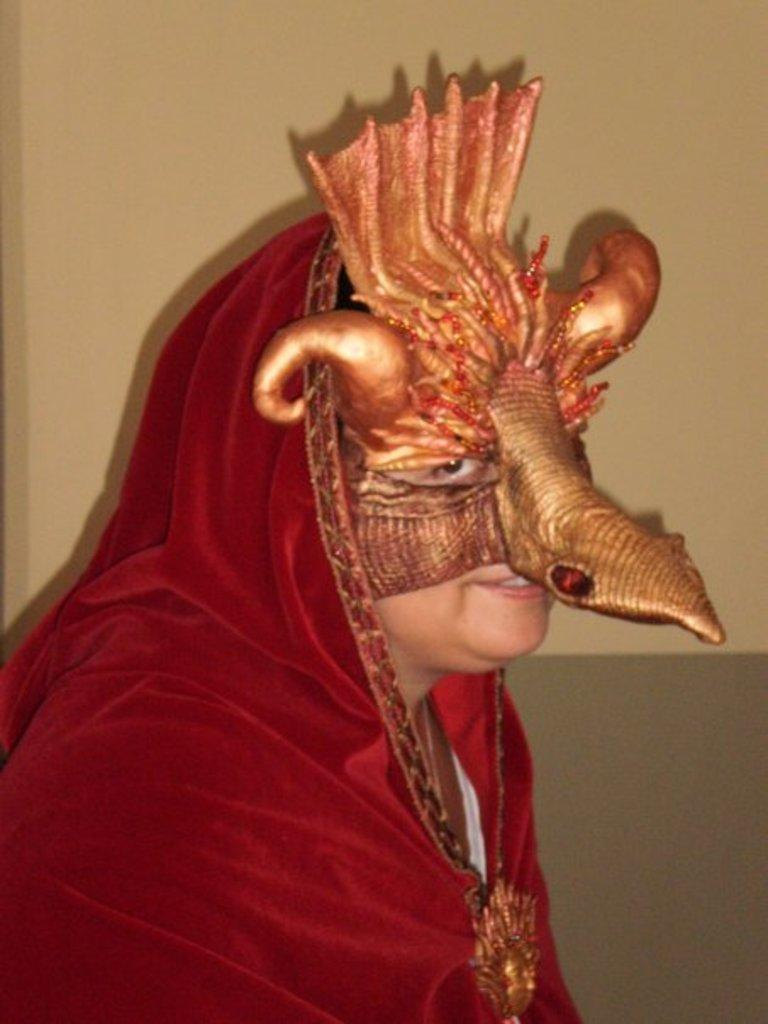What is the person in the image wearing? The person in the image is wearing a costume. What can be seen in the background of the image? There is a wall in the background of the image. How many trucks are parked next to the person in the image? There are no trucks visible in the image; it only features a person wearing a costume and a wall in the background. 